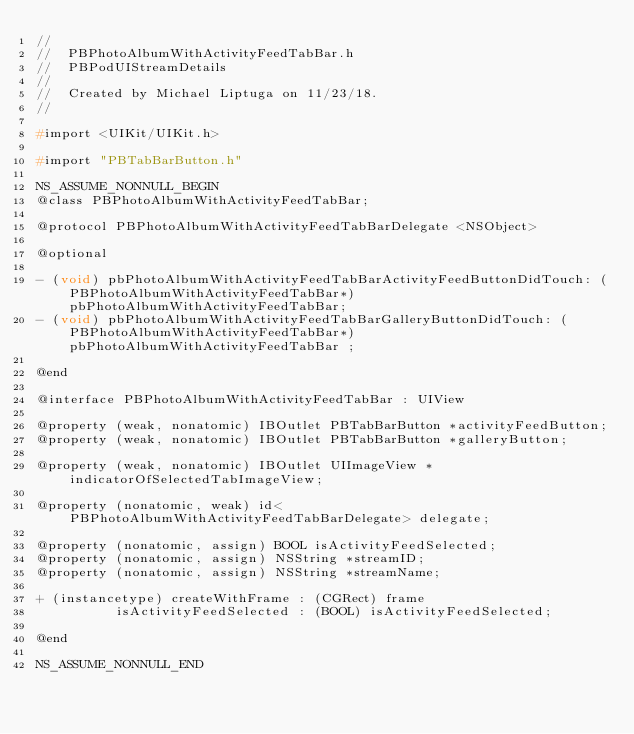Convert code to text. <code><loc_0><loc_0><loc_500><loc_500><_C_>//
//  PBPhotoAlbumWithActivityFeedTabBar.h
//  PBPodUIStreamDetails
//
//  Created by Michael Liptuga on 11/23/18.
//

#import <UIKit/UIKit.h>

#import "PBTabBarButton.h"

NS_ASSUME_NONNULL_BEGIN
@class PBPhotoAlbumWithActivityFeedTabBar;

@protocol PBPhotoAlbumWithActivityFeedTabBarDelegate <NSObject>

@optional

- (void) pbPhotoAlbumWithActivityFeedTabBarActivityFeedButtonDidTouch: (PBPhotoAlbumWithActivityFeedTabBar*) pbPhotoAlbumWithActivityFeedTabBar;
- (void) pbPhotoAlbumWithActivityFeedTabBarGalleryButtonDidTouch: (PBPhotoAlbumWithActivityFeedTabBar*) pbPhotoAlbumWithActivityFeedTabBar ;

@end

@interface PBPhotoAlbumWithActivityFeedTabBar : UIView

@property (weak, nonatomic) IBOutlet PBTabBarButton *activityFeedButton;
@property (weak, nonatomic) IBOutlet PBTabBarButton *galleryButton;

@property (weak, nonatomic) IBOutlet UIImageView *indicatorOfSelectedTabImageView;

@property (nonatomic, weak) id<PBPhotoAlbumWithActivityFeedTabBarDelegate> delegate;

@property (nonatomic, assign) BOOL isActivityFeedSelected;
@property (nonatomic, assign) NSString *streamID;
@property (nonatomic, assign) NSString *streamName;

+ (instancetype) createWithFrame : (CGRect) frame
          isActivityFeedSelected : (BOOL) isActivityFeedSelected;

@end

NS_ASSUME_NONNULL_END
</code> 